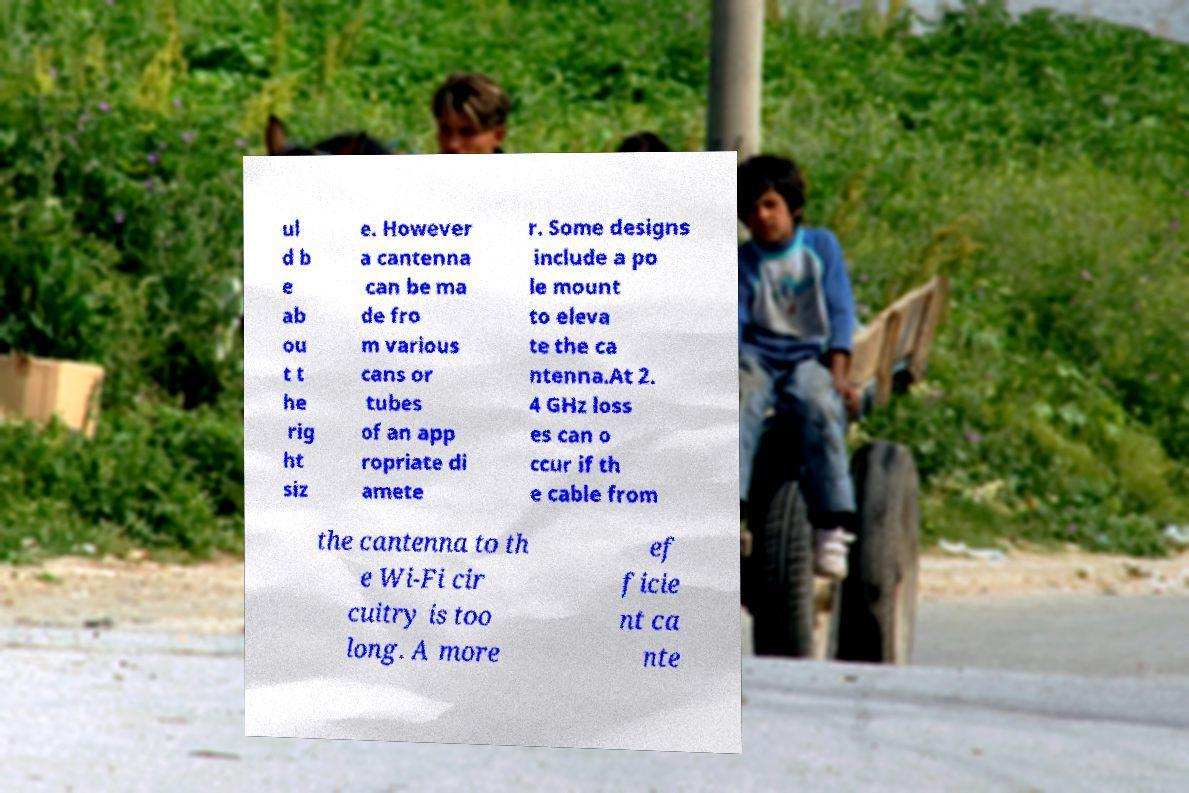Could you extract and type out the text from this image? ul d b e ab ou t t he rig ht siz e. However a cantenna can be ma de fro m various cans or tubes of an app ropriate di amete r. Some designs include a po le mount to eleva te the ca ntenna.At 2. 4 GHz loss es can o ccur if th e cable from the cantenna to th e Wi-Fi cir cuitry is too long. A more ef ficie nt ca nte 